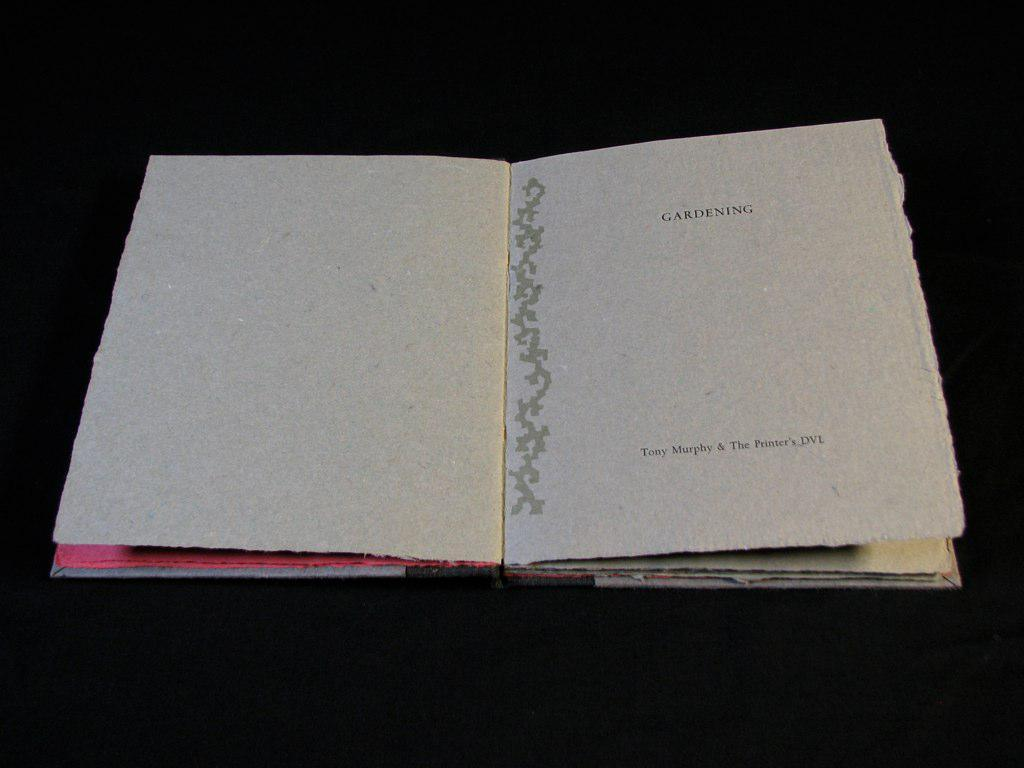Provide a one-sentence caption for the provided image. A book about Gardening sits on a black table. 